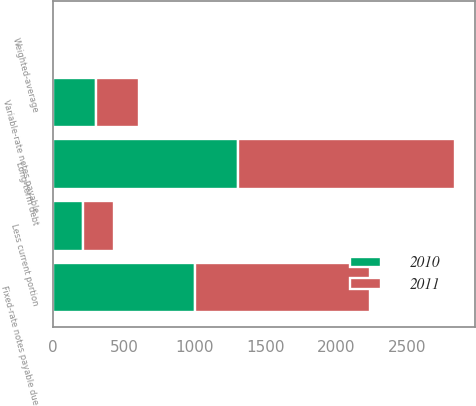<chart> <loc_0><loc_0><loc_500><loc_500><stacked_bar_chart><ecel><fcel>Fixed-rate notes payable due<fcel>Variable-rate notes payable<fcel>Long-term debt<fcel>Less current portion<fcel>Weighted-average<nl><fcel>2010<fcel>1002.5<fcel>304.4<fcel>1306.9<fcel>207.9<fcel>1.9<nl><fcel>2011<fcel>1233.6<fcel>300.6<fcel>1534.2<fcel>221.2<fcel>1.8<nl></chart> 